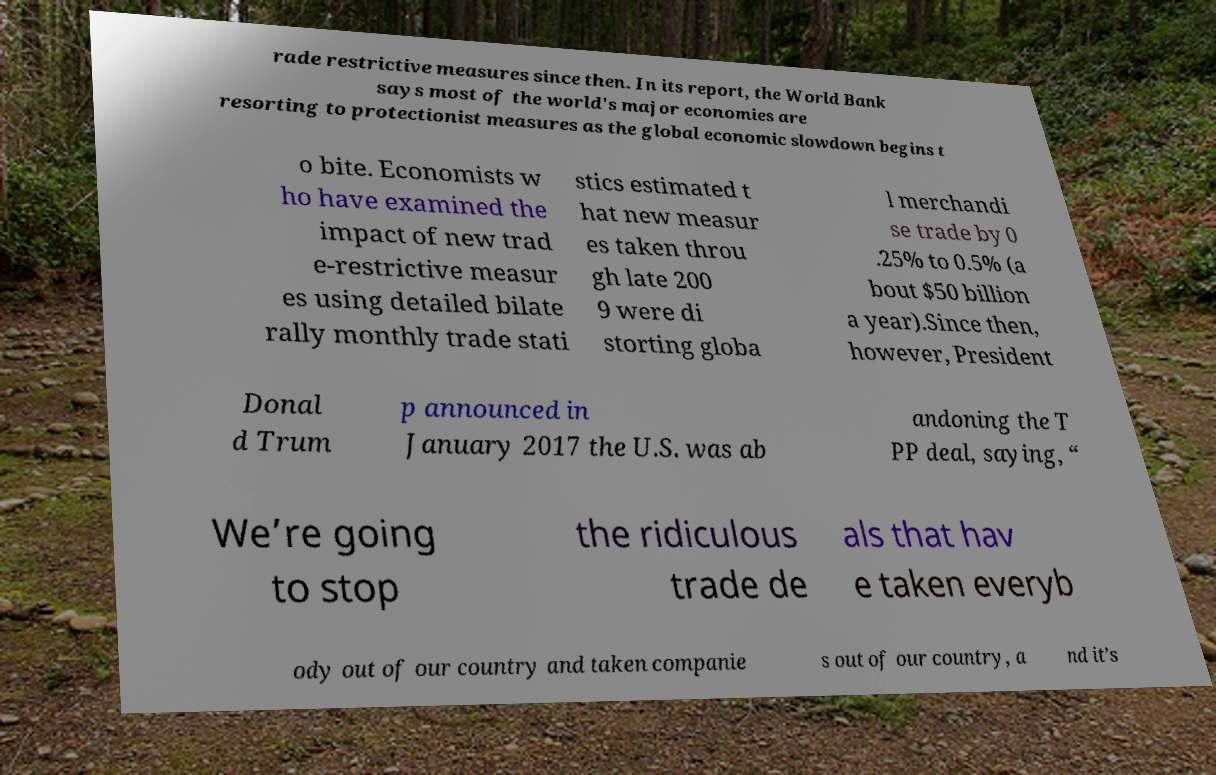Can you accurately transcribe the text from the provided image for me? rade restrictive measures since then. In its report, the World Bank says most of the world's major economies are resorting to protectionist measures as the global economic slowdown begins t o bite. Economists w ho have examined the impact of new trad e-restrictive measur es using detailed bilate rally monthly trade stati stics estimated t hat new measur es taken throu gh late 200 9 were di storting globa l merchandi se trade by 0 .25% to 0.5% (a bout $50 billion a year).Since then, however, President Donal d Trum p announced in January 2017 the U.S. was ab andoning the T PP deal, saying, “ We’re going to stop the ridiculous trade de als that hav e taken everyb ody out of our country and taken companie s out of our country, a nd it’s 